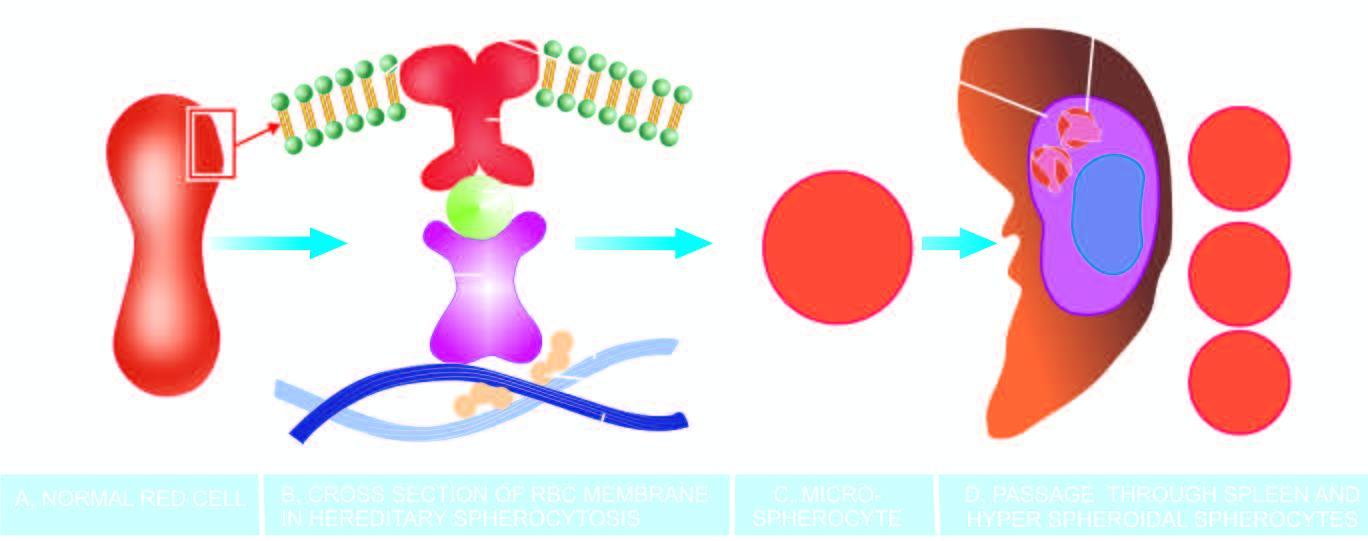what produces a circulating subpopulation of hyperspheroidal spherocytes while splenic macrophages in large numbers phagocytose defective red cells causing splenomegaly?
Answer the question using a single word or phrase. This 